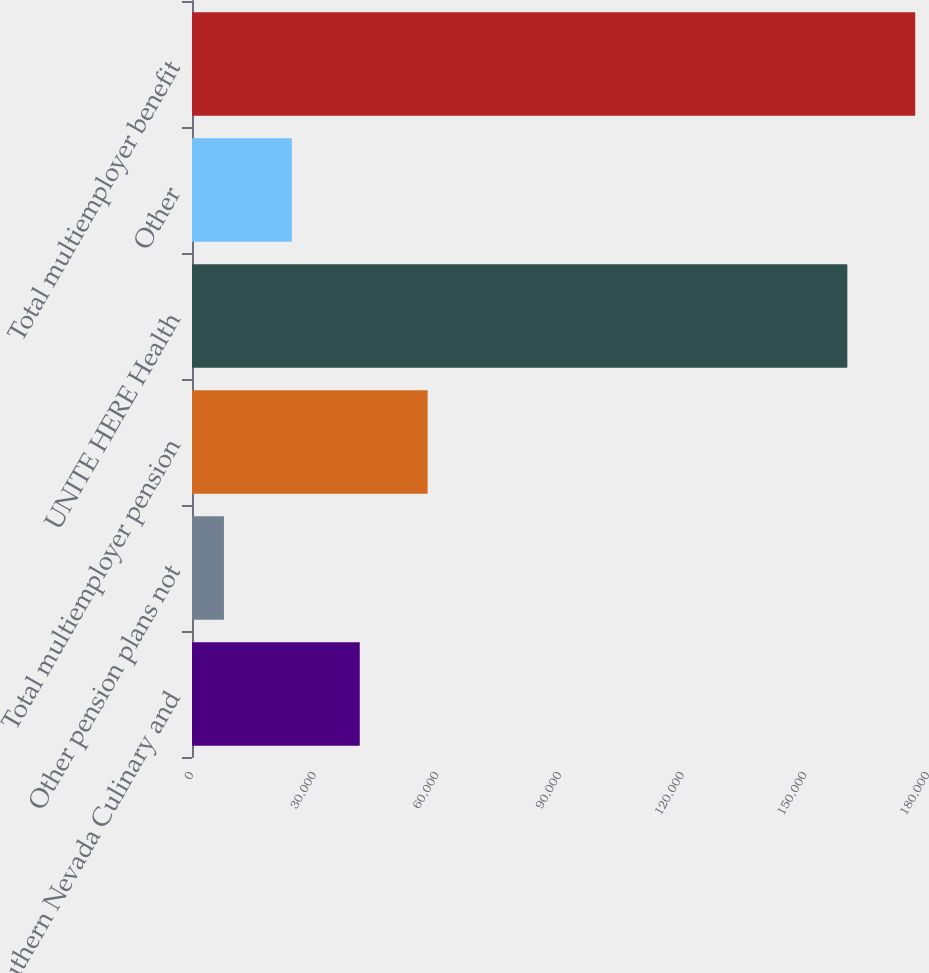Convert chart. <chart><loc_0><loc_0><loc_500><loc_500><bar_chart><fcel>Southern Nevada Culinary and<fcel>Other pension plans not<fcel>Total multiemployer pension<fcel>UNITE HERE Health<fcel>Other<fcel>Total multiemployer benefit<nl><fcel>41025.2<fcel>7812<fcel>57631.8<fcel>160270<fcel>24418.6<fcel>176877<nl></chart> 